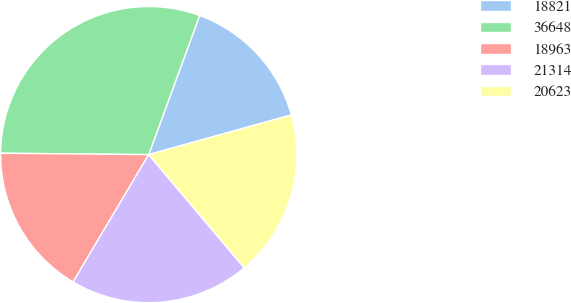Convert chart to OTSL. <chart><loc_0><loc_0><loc_500><loc_500><pie_chart><fcel>18821<fcel>36648<fcel>18963<fcel>21314<fcel>20623<nl><fcel>15.09%<fcel>30.44%<fcel>16.62%<fcel>19.69%<fcel>18.16%<nl></chart> 